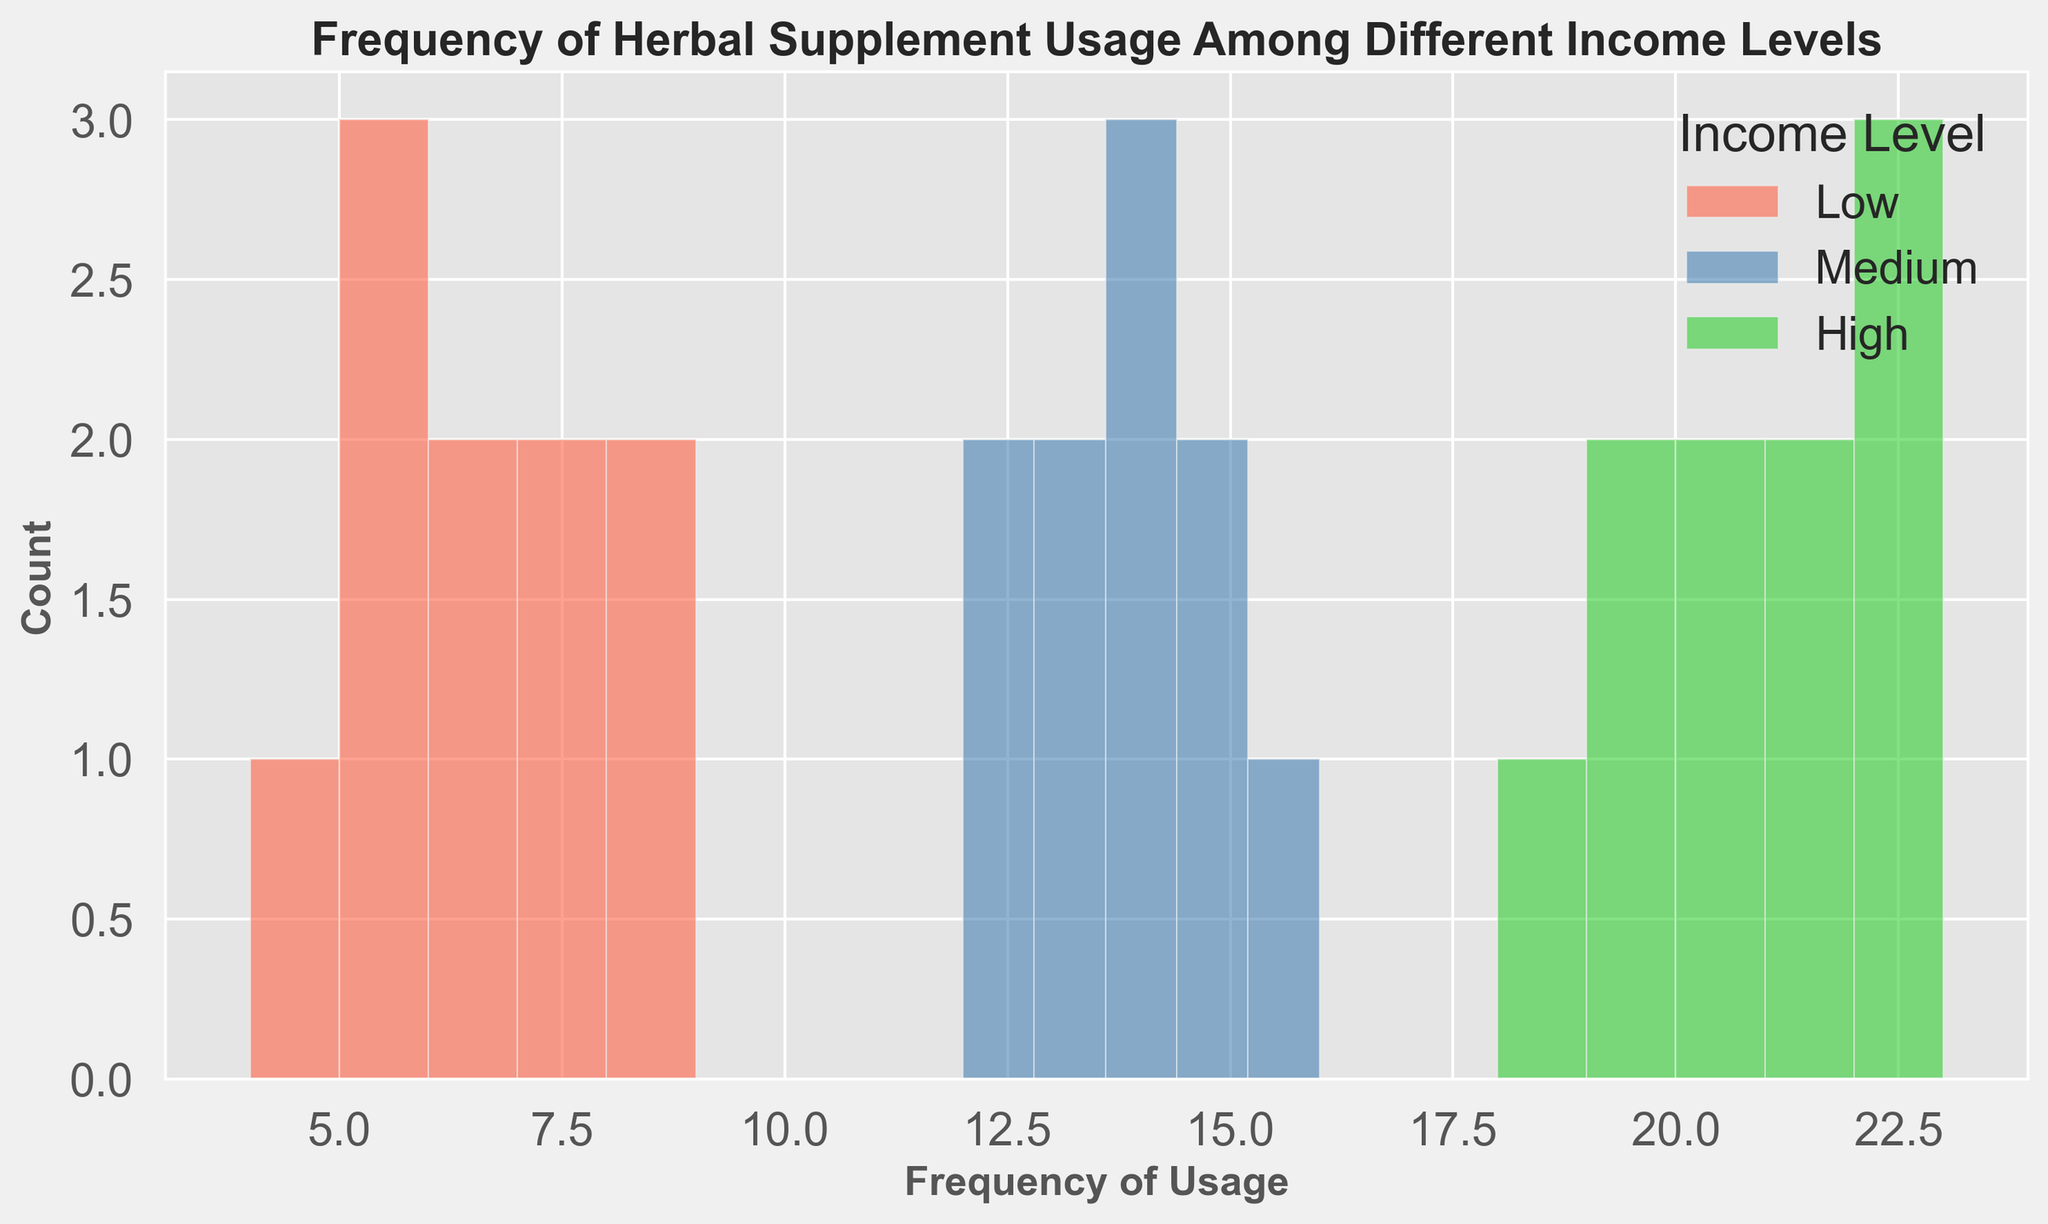What income level group has the highest frequency of herbal supplement usage? Observing the histogram, the "High" income level group shows the highest bars on the rightmost side, indicating that they have the highest frequency of herbal supplement usage.
Answer: High Which income level group shows the most consistent frequency range? By looking at the spread of the bars, the "Low" income level group seems to have a narrower and more consistent frequency range compared to the "Medium" and "High" income groups.
Answer: Low What is the range of frequencies for the "Medium" income level group? The lowest frequency in the "Medium" income level group bins starts from 12, and the highest one is at 16, so the range is from 12 to 16.
Answer: 12-16 Which group has the most variation in the frequency of herbal supplement usage? Comparing the spread and variation of the bars, the "High" income level group spans the widest range, from 18 to 23, indicating the highest variation.
Answer: High How does the frequency of usage for the "Low" income level group compare with the "Medium" income level group? The "Low" income level group appears more concentrated around lower frequencies (4-9), whereas the "Medium" income level group has higher frequencies (12-16).
Answer: Low has lower frequencies than Medium What is the average frequency of herbal supplement usage for the "High" income level group? To find the average, sum up the frequencies for "High" (20 + 22 + 21 + 19 + 18 + 23 + 21 + 20 + 22 + 19 = 205) and divide by the count (10): 205/10 = 20.5
Answer: 20.5 Is there any overlap in the frequency ranges between the "Low" and "Medium" income groups? The "Low" income group ranges from 4 to 9, and the "Medium" ranges from 12 to 16. There is no overlap between these ranges.
Answer: No Which income level group has the tallest bar in the histogram? The "High" income level group shows the tallest bars (greater frequency counts at specific bins) in the histogram.
Answer: High How many bins are shown in the histogram for the "Low" income level group? By counting the bars, there are 5 bins shown for the "Low" income level group in the histogram.
Answer: 5 